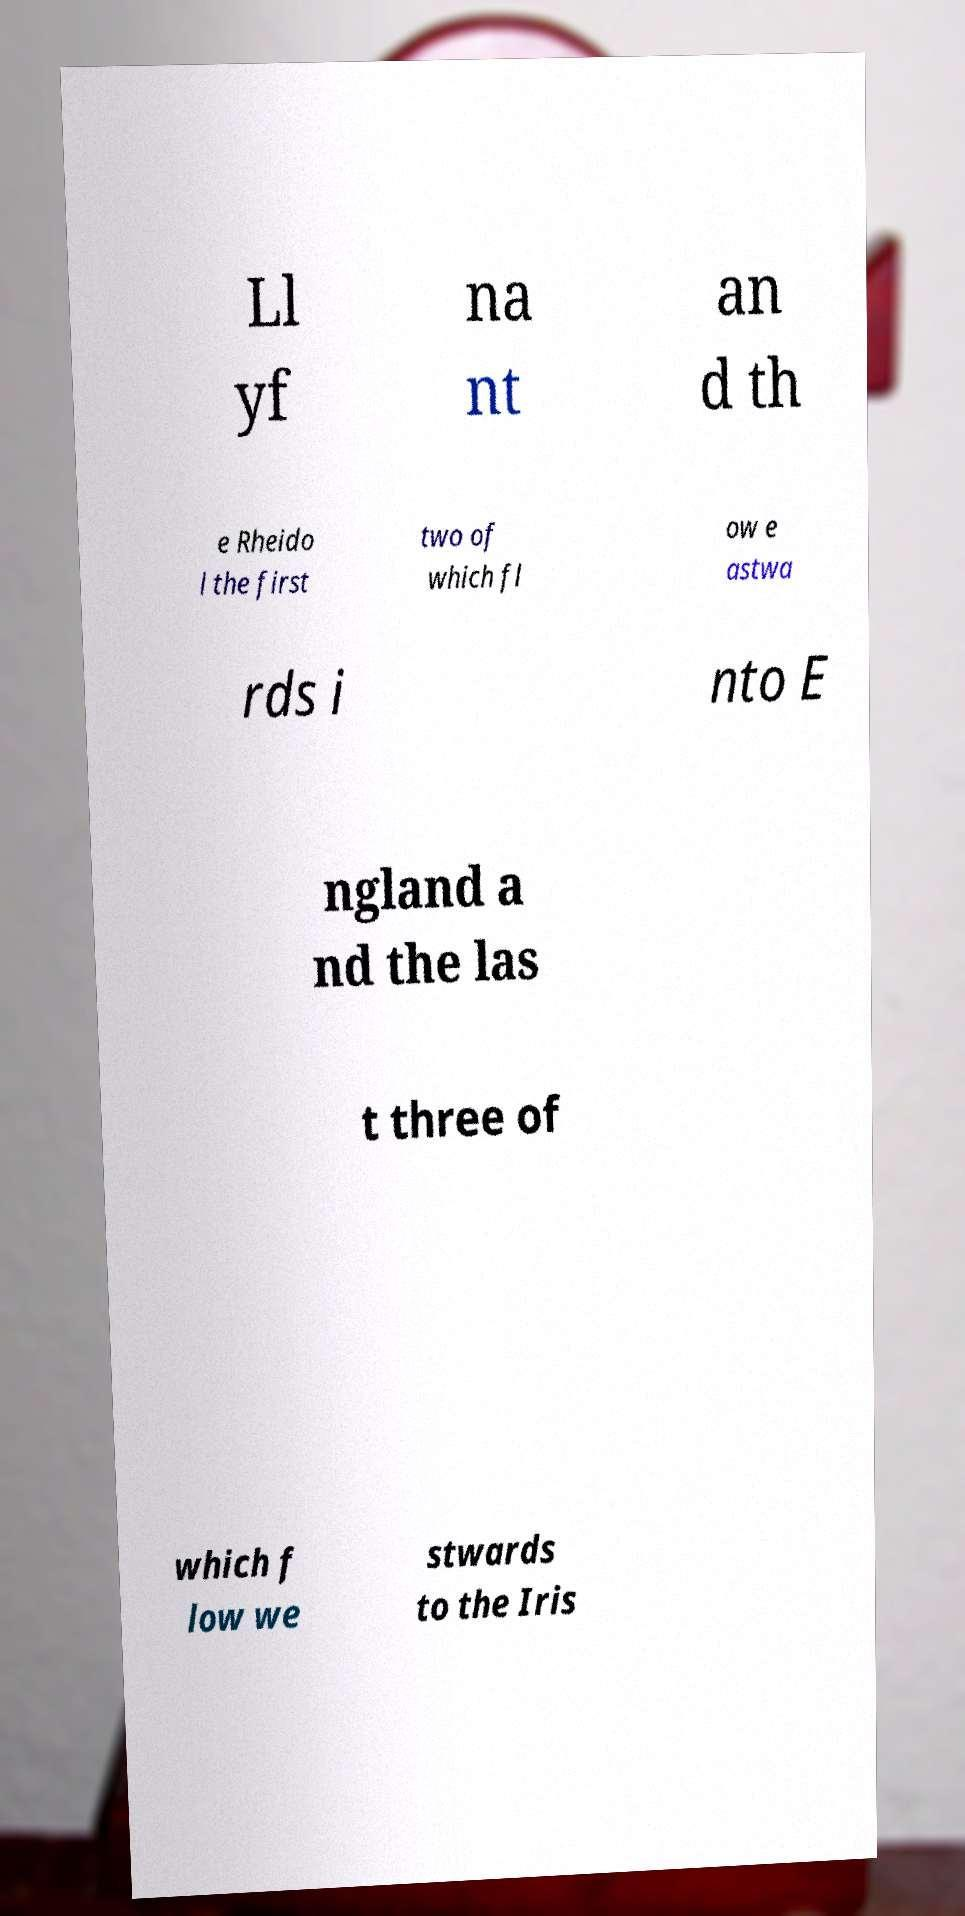I need the written content from this picture converted into text. Can you do that? Ll yf na nt an d th e Rheido l the first two of which fl ow e astwa rds i nto E ngland a nd the las t three of which f low we stwards to the Iris 